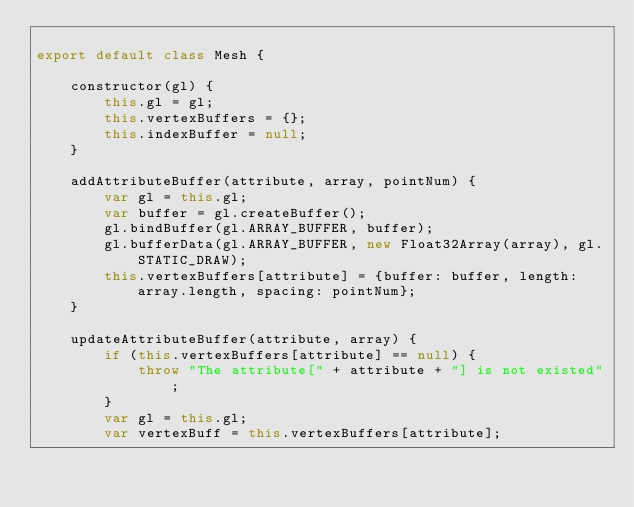Convert code to text. <code><loc_0><loc_0><loc_500><loc_500><_JavaScript_>
export default class Mesh {

    constructor(gl) {
        this.gl = gl;
        this.vertexBuffers = {};
        this.indexBuffer = null;
    }

    addAttributeBuffer(attribute, array, pointNum) {
        var gl = this.gl;
        var buffer = gl.createBuffer();
        gl.bindBuffer(gl.ARRAY_BUFFER, buffer);
        gl.bufferData(gl.ARRAY_BUFFER, new Float32Array(array), gl.STATIC_DRAW);
        this.vertexBuffers[attribute] = {buffer: buffer, length: array.length, spacing: pointNum};
    }

    updateAttributeBuffer(attribute, array) {
        if (this.vertexBuffers[attribute] == null) {
            throw "The attribute[" + attribute + "] is not existed";
        }
        var gl = this.gl;
        var vertexBuff = this.vertexBuffers[attribute];</code> 